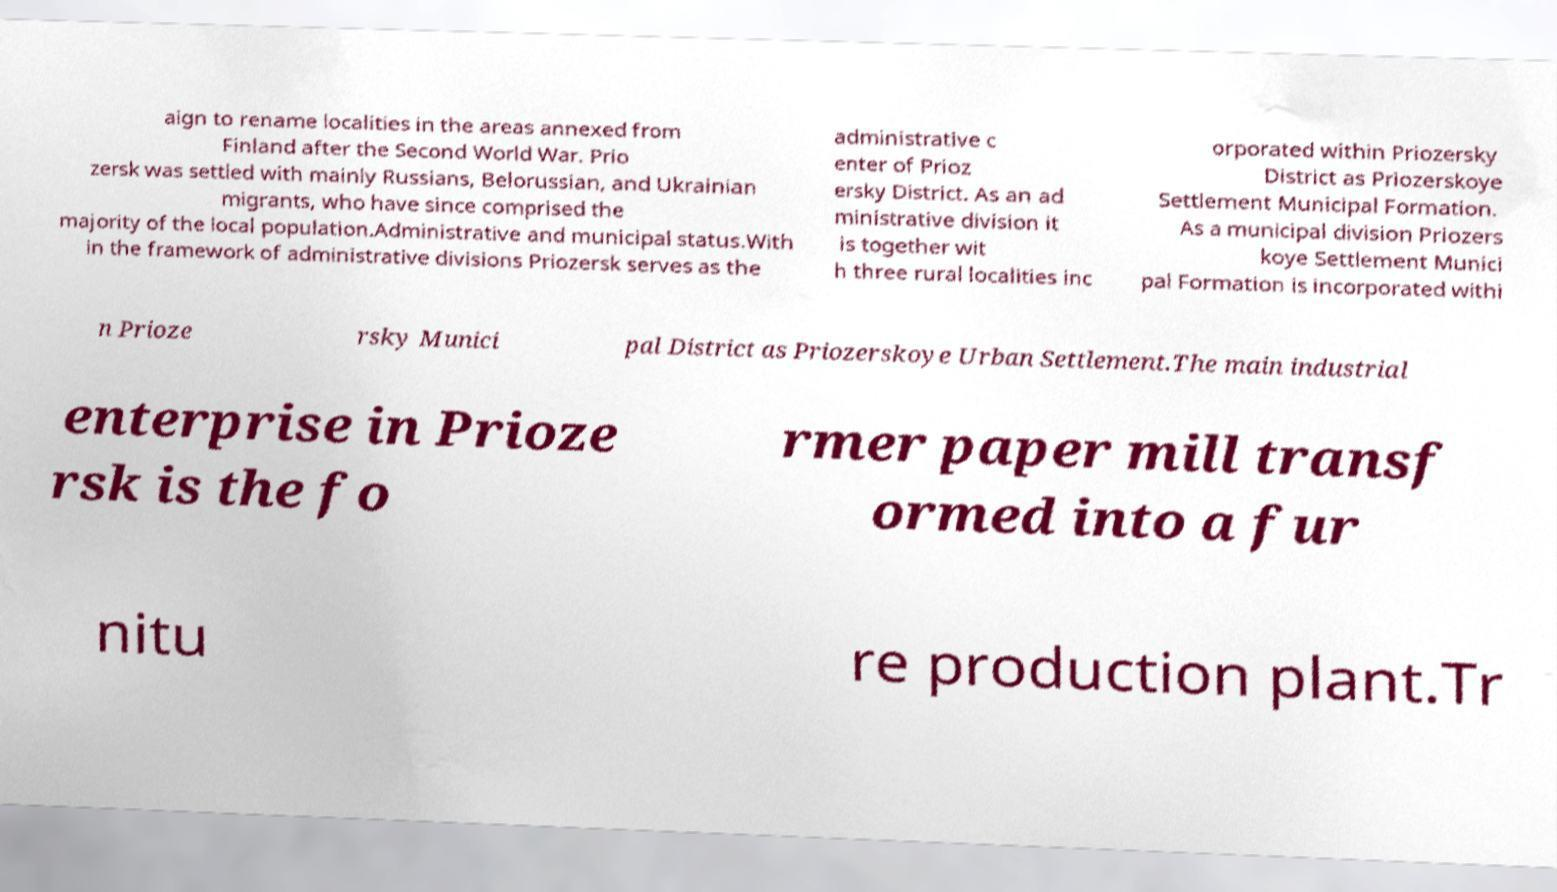I need the written content from this picture converted into text. Can you do that? aign to rename localities in the areas annexed from Finland after the Second World War. Prio zersk was settled with mainly Russians, Belorussian, and Ukrainian migrants, who have since comprised the majority of the local population.Administrative and municipal status.With in the framework of administrative divisions Priozersk serves as the administrative c enter of Prioz ersky District. As an ad ministrative division it is together wit h three rural localities inc orporated within Priozersky District as Priozerskoye Settlement Municipal Formation. As a municipal division Priozers koye Settlement Munici pal Formation is incorporated withi n Prioze rsky Munici pal District as Priozerskoye Urban Settlement.The main industrial enterprise in Prioze rsk is the fo rmer paper mill transf ormed into a fur nitu re production plant.Tr 